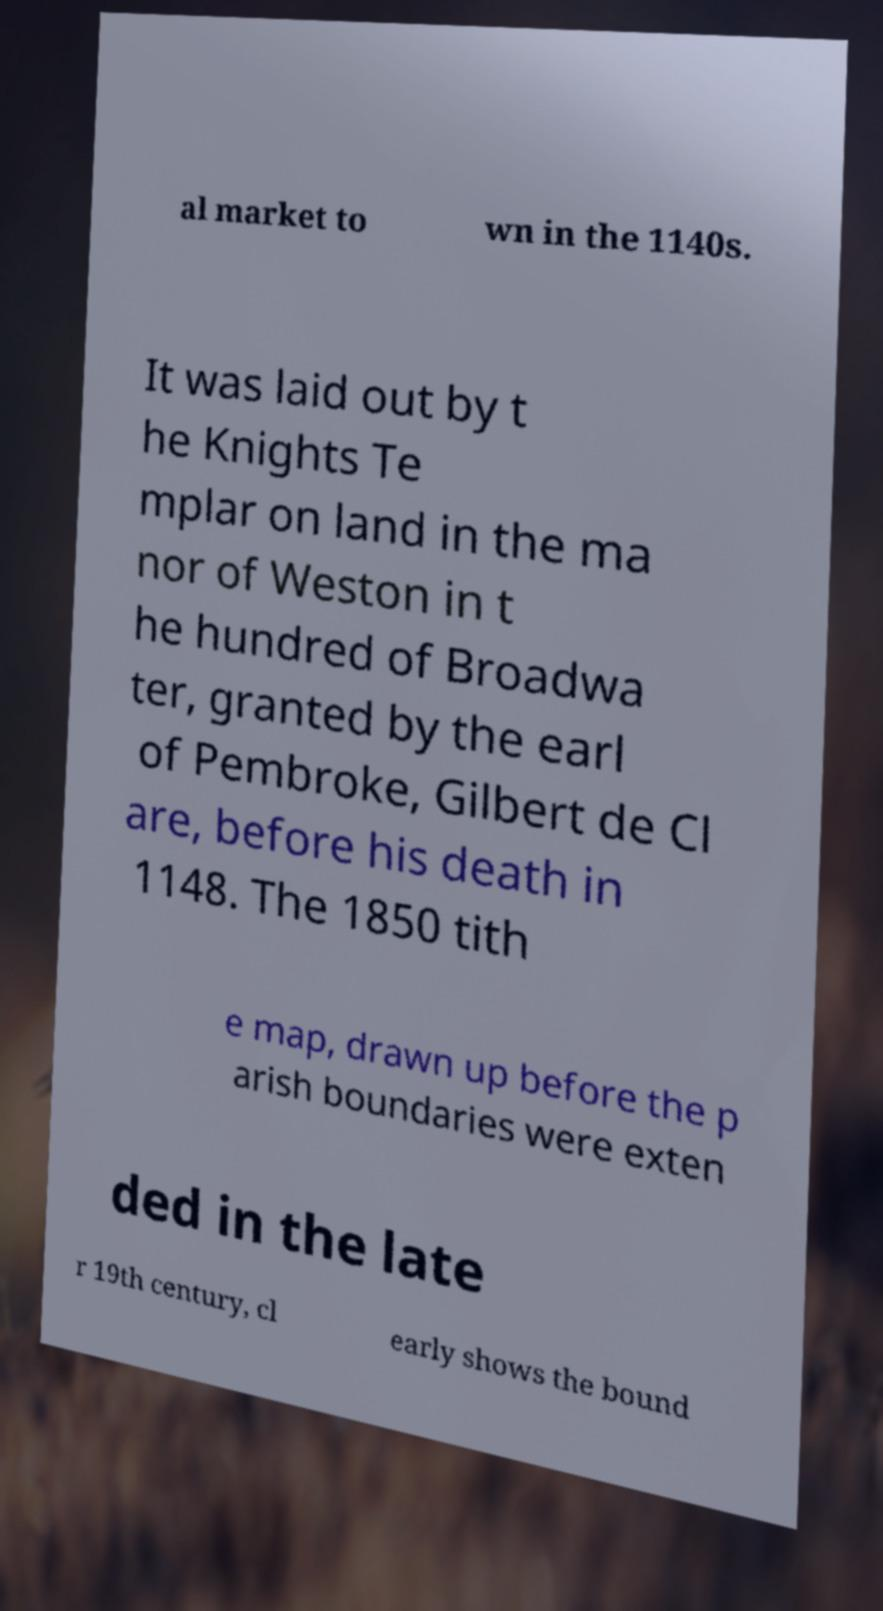Can you read and provide the text displayed in the image?This photo seems to have some interesting text. Can you extract and type it out for me? al market to wn in the 1140s. It was laid out by t he Knights Te mplar on land in the ma nor of Weston in t he hundred of Broadwa ter, granted by the earl of Pembroke, Gilbert de Cl are, before his death in 1148. The 1850 tith e map, drawn up before the p arish boundaries were exten ded in the late r 19th century, cl early shows the bound 